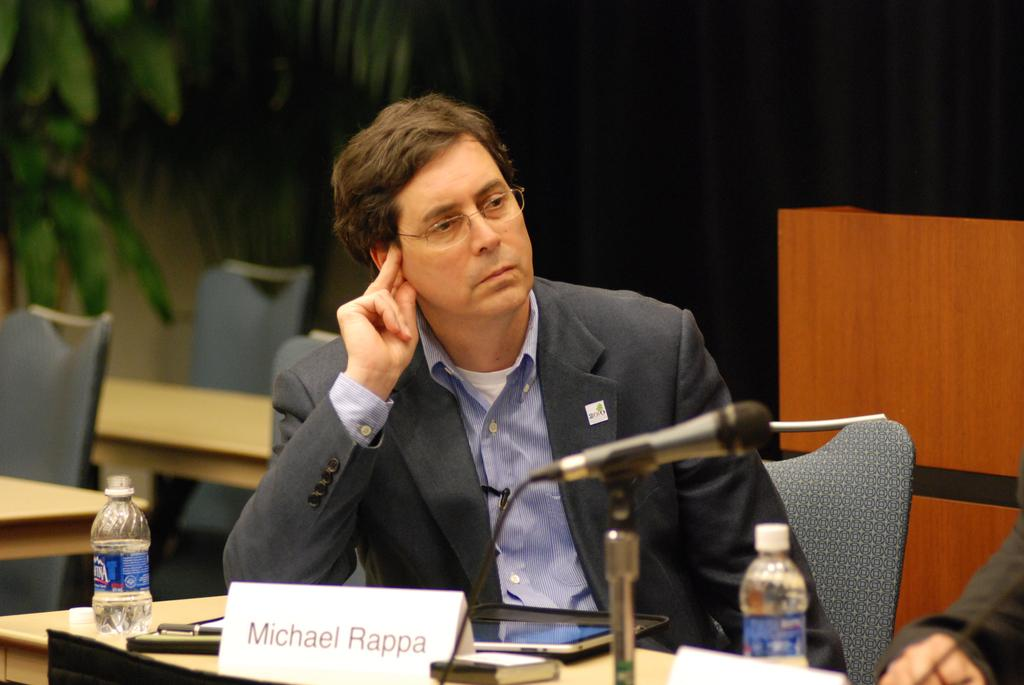What can be seen in the image that represents a living organism? There is a tree in the image that represents a living organism. What is the man in the image doing? The man is sitting on a chair in the image. What is on the table in front of the man? There is a water bottle, a microphone, a poster, and a pen on the table in front of the man. What might the man be using the microphone for? The presence of the microphone suggests that the man might be giving a speech or presentation. What type of team activity is taking place during the rainstorm in the image? There is no team activity or rainstorm present in the image. 